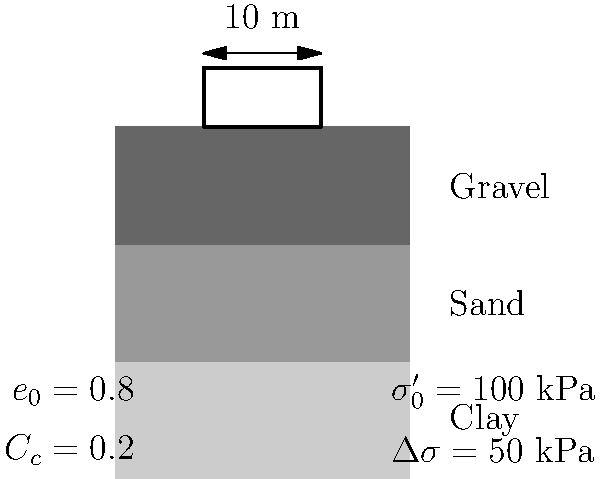A 10-meter wide building foundation is to be constructed on a clay layer as shown in the figure. Given the initial void ratio ($e_0$) of 0.8, compression index ($C_c$) of 0.2, initial effective stress ($\sigma'_0$) of 100 kPa, and an additional stress ($\Delta\sigma$) of 50 kPa due to the building load, estimate the settlement of the building foundation. Assume the clay layer is 5 meters thick. To estimate the settlement of the building foundation, we'll use the consolidation settlement equation for normally consolidated clays:

1. The consolidation settlement equation is:
   $$S = H \cdot \frac{C_c}{1 + e_0} \log_{10}\left(\frac{\sigma'_0 + \Delta\sigma}{\sigma'_0}\right)$$

   Where:
   $S$ = Settlement
   $H$ = Thickness of the clay layer
   $C_c$ = Compression index
   $e_0$ = Initial void ratio
   $\sigma'_0$ = Initial effective stress
   $\Delta\sigma$ = Additional stress due to building load

2. Substituting the given values:
   $H = 5$ m
   $C_c = 0.2$
   $e_0 = 0.8$
   $\sigma'_0 = 100$ kPa
   $\Delta\sigma = 50$ kPa

3. Calculate the settlement:
   $$S = 5 \cdot \frac{0.2}{1 + 0.8} \log_{10}\left(\frac{100 + 50}{100}\right)$$

4. Simplify:
   $$S = 5 \cdot \frac{0.2}{1.8} \log_{10}(1.5)$$

5. Calculate the logarithm:
   $$S = 5 \cdot \frac{0.2}{1.8} \cdot 0.176$$

6. Compute the final result:
   $$S = 0.0978 \text{ m} = 9.78 \text{ cm}$$

Therefore, the estimated settlement of the building foundation is approximately 9.78 cm.
Answer: 9.78 cm 